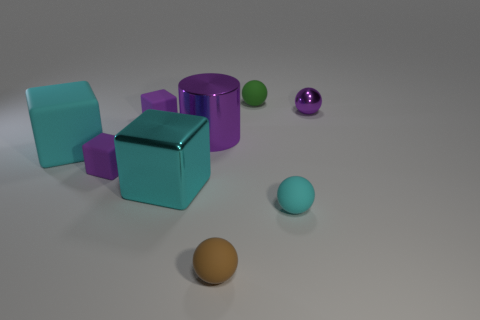What number of purple spheres are behind the metal object that is on the right side of the object that is in front of the tiny cyan rubber object?
Your answer should be compact. 0. What shape is the tiny brown rubber object?
Make the answer very short. Sphere. How many other objects are there of the same material as the cylinder?
Give a very brief answer. 2. Is the size of the green thing the same as the shiny block?
Provide a succinct answer. No. What shape is the purple thing that is right of the small green thing?
Your answer should be very brief. Sphere. What color is the rubber ball that is to the right of the tiny matte sphere behind the tiny shiny object?
Provide a short and direct response. Cyan. Is the shape of the object behind the small purple metal sphere the same as the matte thing to the right of the tiny green thing?
Give a very brief answer. Yes. There is a cyan thing that is the same size as the cyan matte cube; what is its shape?
Make the answer very short. Cube. What is the color of the big block that is made of the same material as the cyan sphere?
Your answer should be very brief. Cyan. Is the shape of the small brown matte object the same as the large metal thing that is in front of the cylinder?
Offer a terse response. No. 